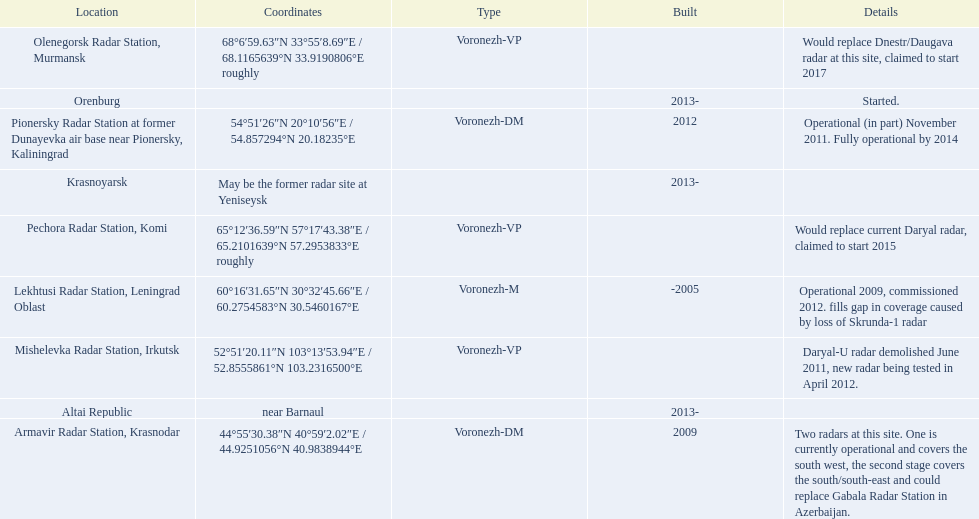What are all of the locations? Lekhtusi Radar Station, Leningrad Oblast, Armavir Radar Station, Krasnodar, Pionersky Radar Station at former Dunayevka air base near Pionersky, Kaliningrad, Mishelevka Radar Station, Irkutsk, Pechora Radar Station, Komi, Olenegorsk Radar Station, Murmansk, Krasnoyarsk, Altai Republic, Orenburg. And which location's coordinates are 60deg16'31.65''n 30deg32'45.66''e / 60.2754583degn 30.5460167dege? Lekhtusi Radar Station, Leningrad Oblast. 